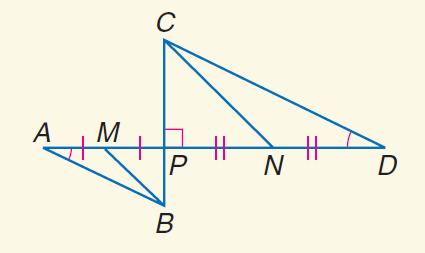Answer the mathemtical geometry problem and directly provide the correct option letter.
Question: Find the perimeter of \triangle C P D if the perimeter of \triangle B P A is 12, B M = \sqrt { 13 }, and C N = 3 \sqrt { 13 }.
Choices: A: 6 B: 12 C: 24 D: 36 D 